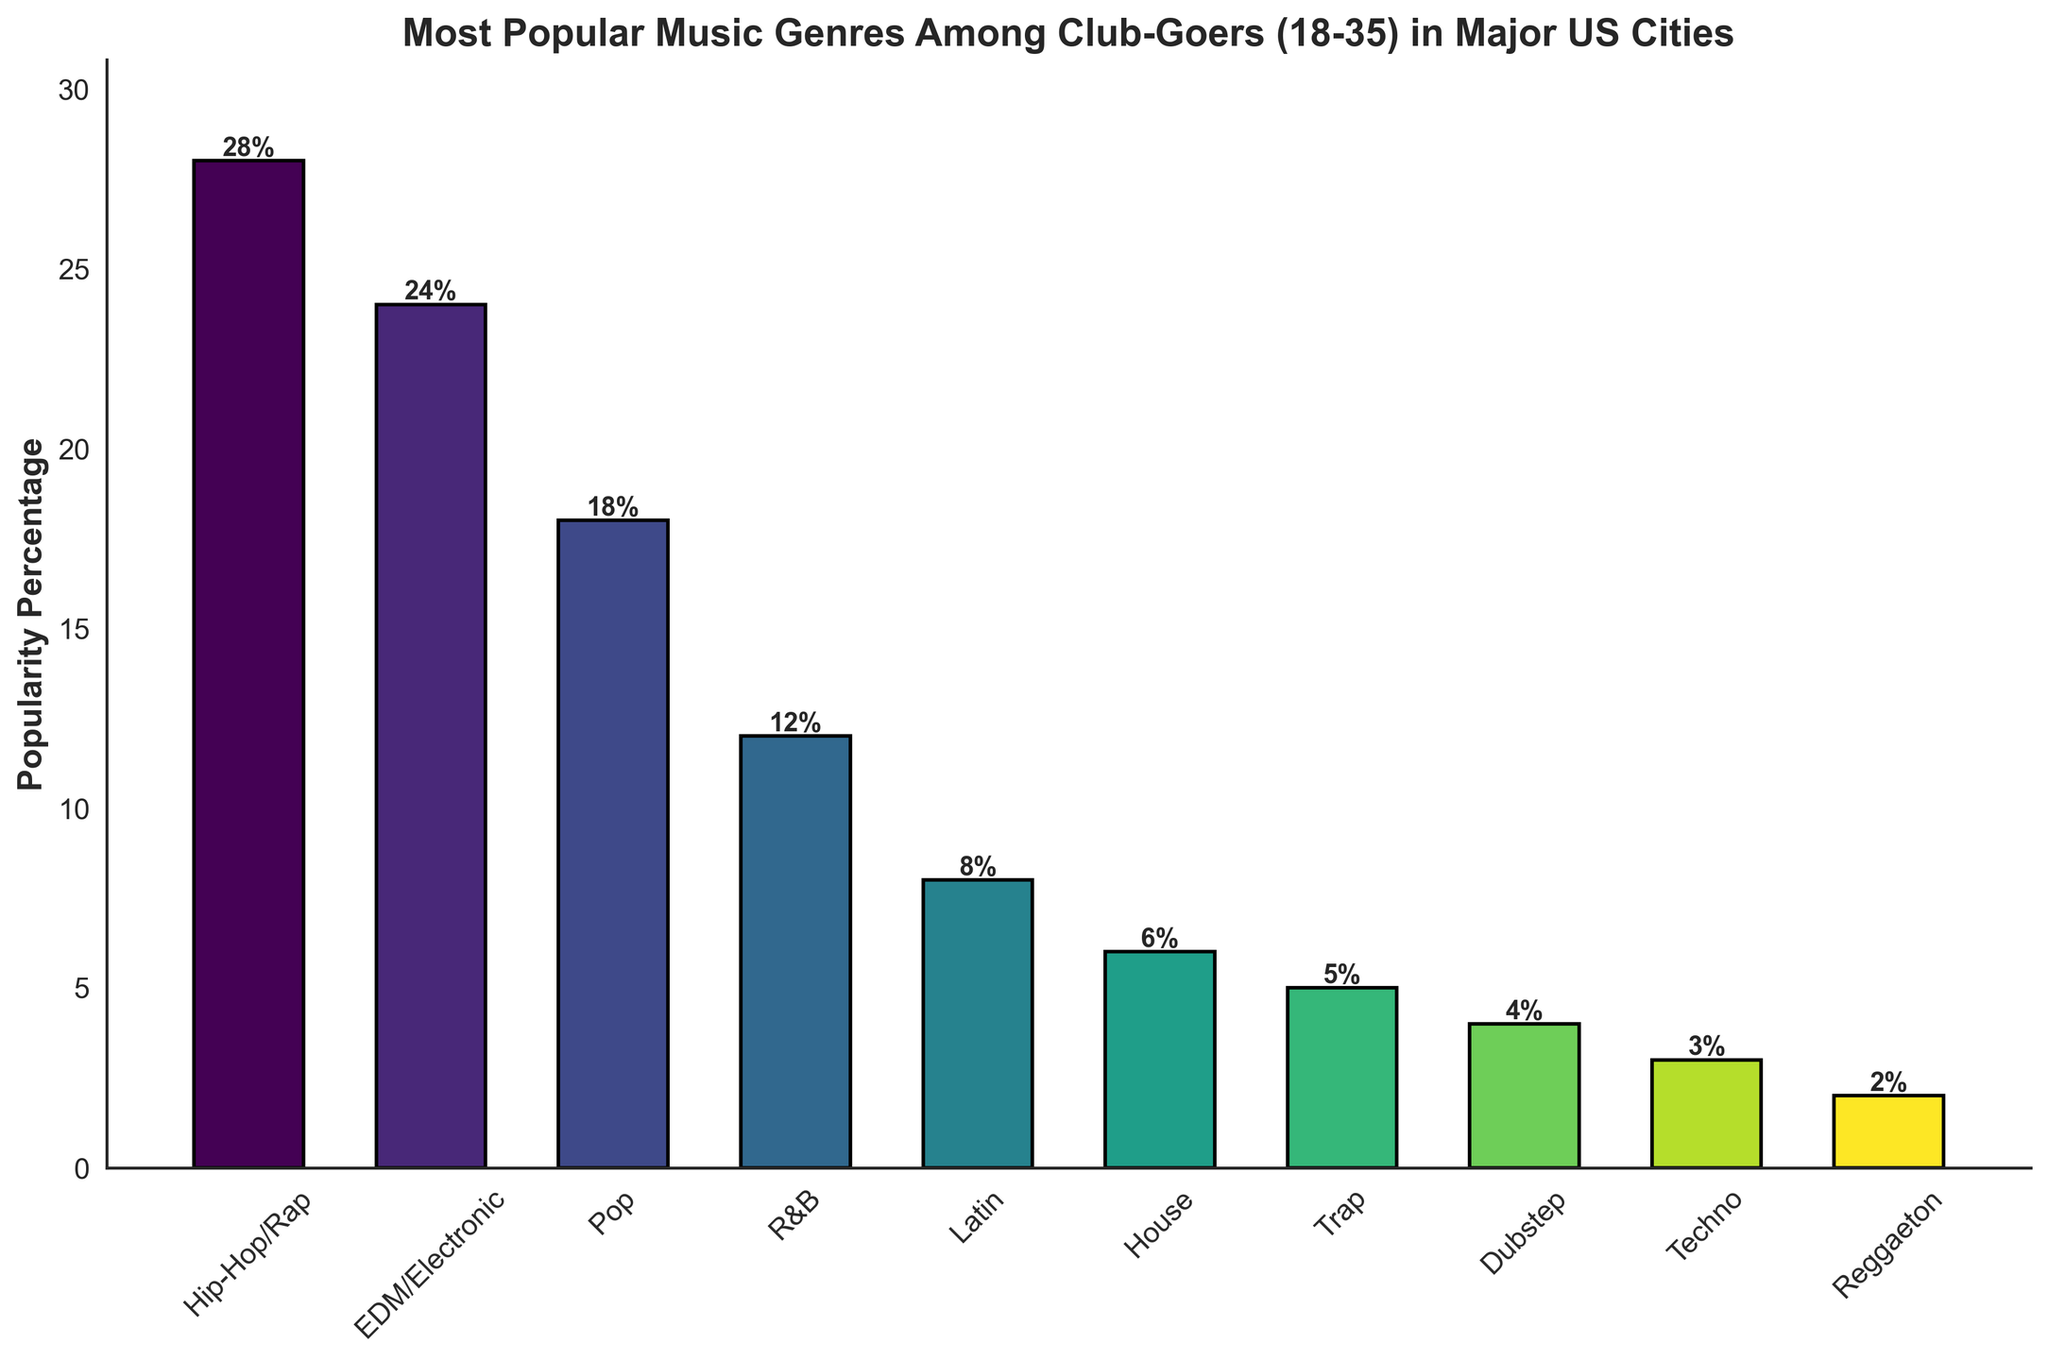What is the most popular music genre among the club-goers aged 18-35? The highest bar represents the most popular genre. Hip-Hop/Rap has the tallest bar at 28%.
Answer: Hip-Hop/Rap Which genre is the second most popular? The second tallest bar indicates the second most popular genre. EDM/Electronic has a popularity of 24%.
Answer: EDM/Electronic What is the combined popularity percentage of Hip-Hop/Rap and EDM/Electronic? Adding the popularity percentages of Hip-Hop/Rap (28%) and EDM/Electronic (24%) gives 28 + 24 = 52.
Answer: 52% Which genre has exactly half the popularity percentage of Hip-Hop/Rap? Half of Hip-Hop/Rap's popularity percentage is 28 / 2 = 14. The genre closest to this is R&B with 12%.
Answer: R&B What is the color of the bar representing Pop music? The color representing each genre is derived from a viridis color gradient. Observing the middle of the gradient around Pop should give a color detail.
Answer: Dependent on visual (Viridis color gradient, typically greenish) Which genre has the least popularity percentage and what is it? The shortest bar represents the least popularity percentage. Reggaeton has the shortest bar at 2%.
Answer: Reggaeton How much more popular is Hip-Hop/Rap than House? The difference in their popularity percentages is 28% (Hip-Hop/Rap) - 6% (House) = 22%.
Answer: 22% What genres have a popularity percentage greater than 20%? Checking the bars taller than the one representing 20% reveals Hip-Hop/Rap (28%) and EDM/Electronic (24%).
Answer: Hip-Hop/Rap, EDM/Electronic What is the average popularity percentage of all the genres? Adding all the popularity percentages and dividing by the number of genres: (28+24+18+12+8+6+5+4+3+2)/10 = 11.
Answer: 11% What is the popularity percentage of the genre with the yellowish-green bar? Yellowish-green typically represents a middle value on the viridis scale. Pop is generally around this area with 18%.
Answer: 18% 